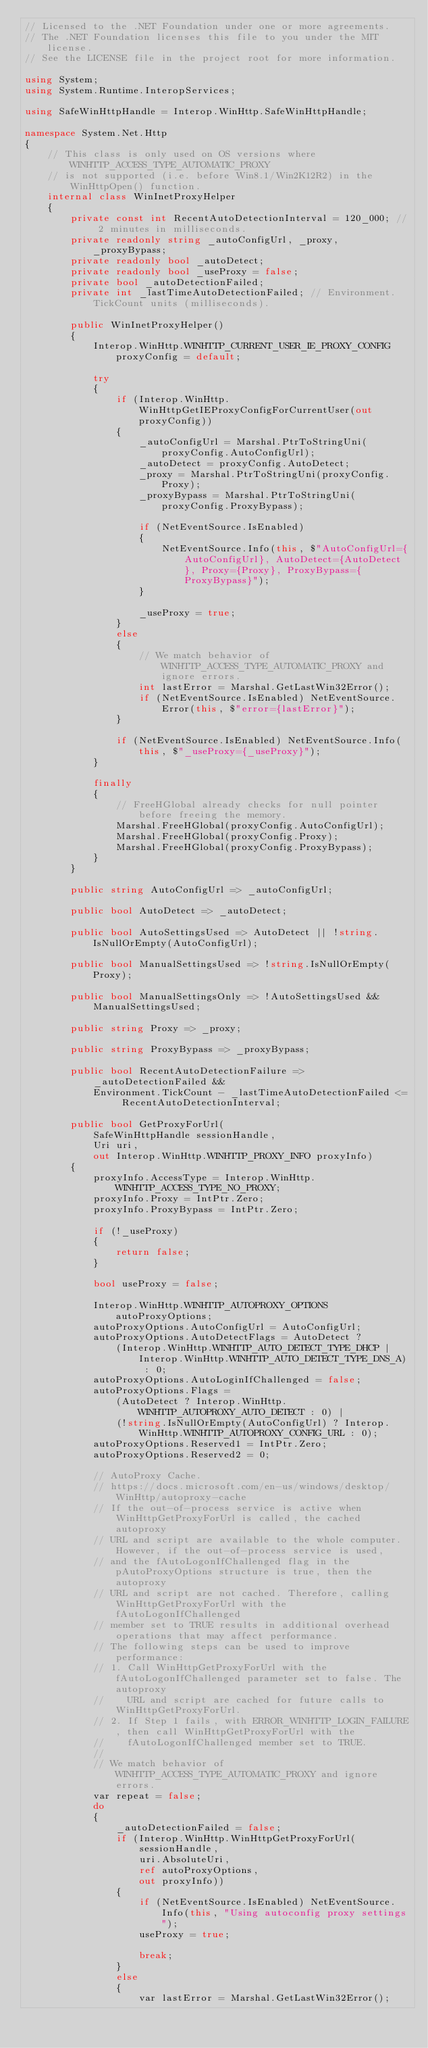Convert code to text. <code><loc_0><loc_0><loc_500><loc_500><_C#_>// Licensed to the .NET Foundation under one or more agreements.
// The .NET Foundation licenses this file to you under the MIT license.
// See the LICENSE file in the project root for more information.

using System;
using System.Runtime.InteropServices;

using SafeWinHttpHandle = Interop.WinHttp.SafeWinHttpHandle;

namespace System.Net.Http
{
    // This class is only used on OS versions where WINHTTP_ACCESS_TYPE_AUTOMATIC_PROXY
    // is not supported (i.e. before Win8.1/Win2K12R2) in the WinHttpOpen() function.
    internal class WinInetProxyHelper
    {
        private const int RecentAutoDetectionInterval = 120_000; // 2 minutes in milliseconds.
        private readonly string _autoConfigUrl, _proxy, _proxyBypass;
        private readonly bool _autoDetect;
        private readonly bool _useProxy = false;
        private bool _autoDetectionFailed;
        private int _lastTimeAutoDetectionFailed; // Environment.TickCount units (milliseconds).

        public WinInetProxyHelper()
        {
            Interop.WinHttp.WINHTTP_CURRENT_USER_IE_PROXY_CONFIG proxyConfig = default;

            try
            {
                if (Interop.WinHttp.WinHttpGetIEProxyConfigForCurrentUser(out proxyConfig))
                {
                    _autoConfigUrl = Marshal.PtrToStringUni(proxyConfig.AutoConfigUrl);
                    _autoDetect = proxyConfig.AutoDetect;
                    _proxy = Marshal.PtrToStringUni(proxyConfig.Proxy);
                    _proxyBypass = Marshal.PtrToStringUni(proxyConfig.ProxyBypass);

                    if (NetEventSource.IsEnabled)
                    {
                        NetEventSource.Info(this, $"AutoConfigUrl={AutoConfigUrl}, AutoDetect={AutoDetect}, Proxy={Proxy}, ProxyBypass={ProxyBypass}");
                    }

                    _useProxy = true;
                }
                else
                {
                    // We match behavior of WINHTTP_ACCESS_TYPE_AUTOMATIC_PROXY and ignore errors.
                    int lastError = Marshal.GetLastWin32Error();
                    if (NetEventSource.IsEnabled) NetEventSource.Error(this, $"error={lastError}");
                }

                if (NetEventSource.IsEnabled) NetEventSource.Info(this, $"_useProxy={_useProxy}");
            }

            finally
            {
                // FreeHGlobal already checks for null pointer before freeing the memory.
                Marshal.FreeHGlobal(proxyConfig.AutoConfigUrl);
                Marshal.FreeHGlobal(proxyConfig.Proxy);
                Marshal.FreeHGlobal(proxyConfig.ProxyBypass);
            }
        }

        public string AutoConfigUrl => _autoConfigUrl;

        public bool AutoDetect => _autoDetect;

        public bool AutoSettingsUsed => AutoDetect || !string.IsNullOrEmpty(AutoConfigUrl);

        public bool ManualSettingsUsed => !string.IsNullOrEmpty(Proxy);

        public bool ManualSettingsOnly => !AutoSettingsUsed && ManualSettingsUsed;

        public string Proxy => _proxy;

        public string ProxyBypass => _proxyBypass;

        public bool RecentAutoDetectionFailure =>
            _autoDetectionFailed &&
            Environment.TickCount - _lastTimeAutoDetectionFailed <= RecentAutoDetectionInterval;

        public bool GetProxyForUrl(
            SafeWinHttpHandle sessionHandle,
            Uri uri,
            out Interop.WinHttp.WINHTTP_PROXY_INFO proxyInfo)
        {
            proxyInfo.AccessType = Interop.WinHttp.WINHTTP_ACCESS_TYPE_NO_PROXY;
            proxyInfo.Proxy = IntPtr.Zero;
            proxyInfo.ProxyBypass = IntPtr.Zero;

            if (!_useProxy)
            {
                return false;
            }

            bool useProxy = false;

            Interop.WinHttp.WINHTTP_AUTOPROXY_OPTIONS autoProxyOptions;
            autoProxyOptions.AutoConfigUrl = AutoConfigUrl;
            autoProxyOptions.AutoDetectFlags = AutoDetect ?
                (Interop.WinHttp.WINHTTP_AUTO_DETECT_TYPE_DHCP | Interop.WinHttp.WINHTTP_AUTO_DETECT_TYPE_DNS_A) : 0;
            autoProxyOptions.AutoLoginIfChallenged = false;
            autoProxyOptions.Flags =
                (AutoDetect ? Interop.WinHttp.WINHTTP_AUTOPROXY_AUTO_DETECT : 0) |
                (!string.IsNullOrEmpty(AutoConfigUrl) ? Interop.WinHttp.WINHTTP_AUTOPROXY_CONFIG_URL : 0);
            autoProxyOptions.Reserved1 = IntPtr.Zero;
            autoProxyOptions.Reserved2 = 0;

            // AutoProxy Cache.
            // https://docs.microsoft.com/en-us/windows/desktop/WinHttp/autoproxy-cache
            // If the out-of-process service is active when WinHttpGetProxyForUrl is called, the cached autoproxy
            // URL and script are available to the whole computer. However, if the out-of-process service is used,
            // and the fAutoLogonIfChallenged flag in the pAutoProxyOptions structure is true, then the autoproxy
            // URL and script are not cached. Therefore, calling WinHttpGetProxyForUrl with the fAutoLogonIfChallenged
            // member set to TRUE results in additional overhead operations that may affect performance.
            // The following steps can be used to improve performance:
            // 1. Call WinHttpGetProxyForUrl with the fAutoLogonIfChallenged parameter set to false. The autoproxy
            //    URL and script are cached for future calls to WinHttpGetProxyForUrl.
            // 2. If Step 1 fails, with ERROR_WINHTTP_LOGIN_FAILURE, then call WinHttpGetProxyForUrl with the
            //    fAutoLogonIfChallenged member set to TRUE.
            //
            // We match behavior of WINHTTP_ACCESS_TYPE_AUTOMATIC_PROXY and ignore errors.
            var repeat = false;
            do
            {
                _autoDetectionFailed = false;
                if (Interop.WinHttp.WinHttpGetProxyForUrl(
                    sessionHandle,
                    uri.AbsoluteUri,
                    ref autoProxyOptions,
                    out proxyInfo))
                {
                    if (NetEventSource.IsEnabled) NetEventSource.Info(this, "Using autoconfig proxy settings");
                    useProxy = true;

                    break;
                }
                else
                {
                    var lastError = Marshal.GetLastWin32Error();</code> 